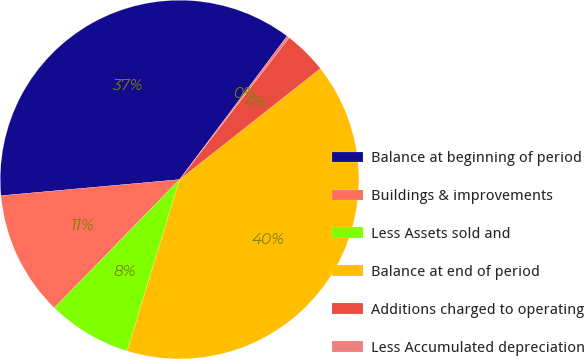Convert chart to OTSL. <chart><loc_0><loc_0><loc_500><loc_500><pie_chart><fcel>Balance at beginning of period<fcel>Buildings & improvements<fcel>Less Assets sold and<fcel>Balance at end of period<fcel>Additions charged to operating<fcel>Less Accumulated depreciation<nl><fcel>36.67%<fcel>11.26%<fcel>7.58%<fcel>40.35%<fcel>3.91%<fcel>0.23%<nl></chart> 